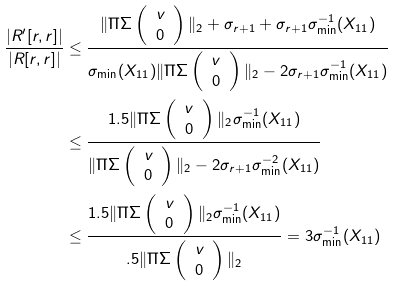Convert formula to latex. <formula><loc_0><loc_0><loc_500><loc_500>\frac { | R ^ { \prime } [ r , r ] | } { | R [ r , r ] | } & \leq \frac { \| \Pi \Sigma \left ( \begin{array} { c } v \\ 0 \end{array} \right ) \| _ { 2 } + \sigma _ { r + 1 } + \sigma _ { r + 1 } \sigma _ { \min } ^ { - 1 } ( X _ { 1 1 } ) } { \sigma _ { \min } ( X _ { 1 1 } ) \| \Pi \Sigma \left ( \begin{array} { c } v \\ 0 \end{array} \right ) \| _ { 2 } - 2 \sigma _ { r + 1 } \sigma _ { \min } ^ { - 1 } ( X _ { 1 1 } ) } \\ & \leq \frac { 1 . 5 \| \Pi \Sigma \left ( \begin{array} { c } v \\ 0 \end{array} \right ) \| _ { 2 } \sigma _ { \min } ^ { - 1 } ( X _ { 1 1 } ) } { \| \Pi \Sigma \left ( \begin{array} { c } v \\ 0 \end{array} \right ) \| _ { 2 } - 2 \sigma _ { r + 1 } \sigma _ { \min } ^ { - 2 } ( X _ { 1 1 } ) } \\ & \leq \frac { 1 . 5 \| \Pi \Sigma \left ( \begin{array} { c } v \\ 0 \end{array} \right ) \| _ { 2 } \sigma _ { \min } ^ { - 1 } ( X _ { 1 1 } ) } { . 5 \| \Pi \Sigma \left ( \begin{array} { c } v \\ 0 \end{array} \right ) \| _ { 2 } } = 3 \sigma _ { \min } ^ { - 1 } ( X _ { 1 1 } )</formula> 